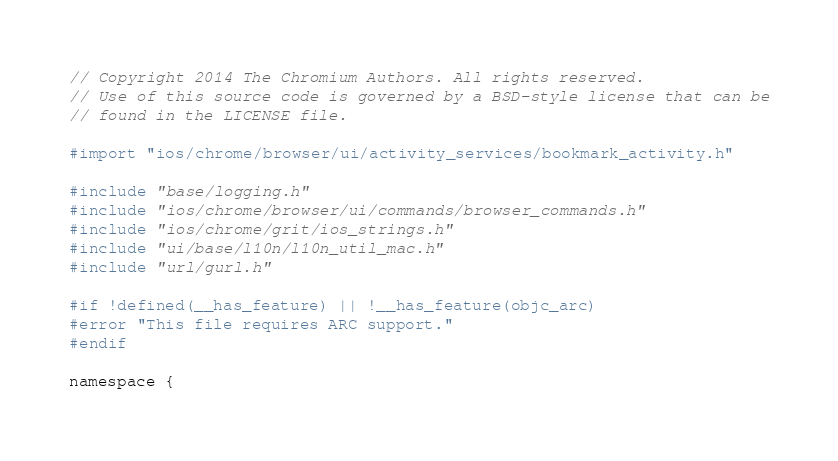<code> <loc_0><loc_0><loc_500><loc_500><_ObjectiveC_>// Copyright 2014 The Chromium Authors. All rights reserved.
// Use of this source code is governed by a BSD-style license that can be
// found in the LICENSE file.

#import "ios/chrome/browser/ui/activity_services/bookmark_activity.h"

#include "base/logging.h"
#include "ios/chrome/browser/ui/commands/browser_commands.h"
#include "ios/chrome/grit/ios_strings.h"
#include "ui/base/l10n/l10n_util_mac.h"
#include "url/gurl.h"

#if !defined(__has_feature) || !__has_feature(objc_arc)
#error "This file requires ARC support."
#endif

namespace {
</code> 